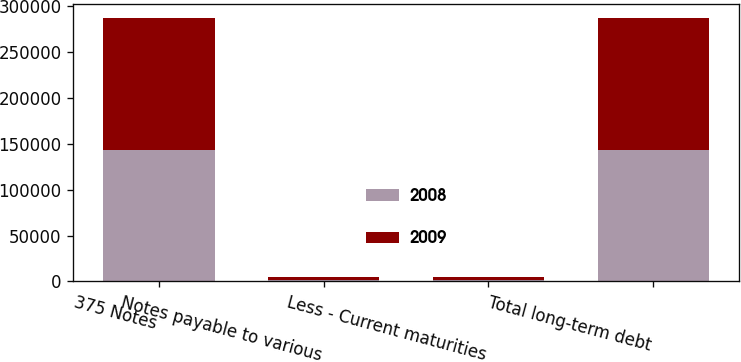<chart> <loc_0><loc_0><loc_500><loc_500><stacked_bar_chart><ecel><fcel>375 Notes<fcel>Notes payable to various<fcel>Less - Current maturities<fcel>Total long-term debt<nl><fcel>2008<fcel>143750<fcel>1155<fcel>1155<fcel>143750<nl><fcel>2009<fcel>143750<fcel>3426<fcel>3426<fcel>143750<nl></chart> 